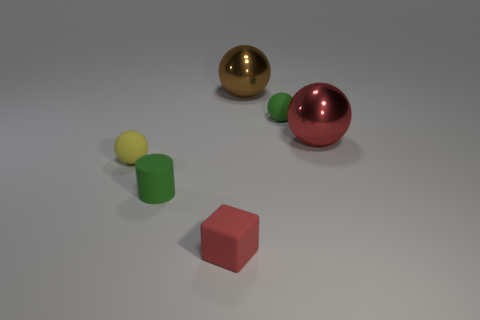Add 4 matte objects. How many objects exist? 10 Subtract all small green spheres. How many spheres are left? 3 Subtract all green spheres. How many spheres are left? 3 Subtract all cylinders. How many objects are left? 5 Subtract all tiny brown metal things. Subtract all tiny spheres. How many objects are left? 4 Add 2 tiny green spheres. How many tiny green spheres are left? 3 Add 5 large shiny balls. How many large shiny balls exist? 7 Subtract 0 gray cylinders. How many objects are left? 6 Subtract 1 spheres. How many spheres are left? 3 Subtract all gray balls. Subtract all cyan cubes. How many balls are left? 4 